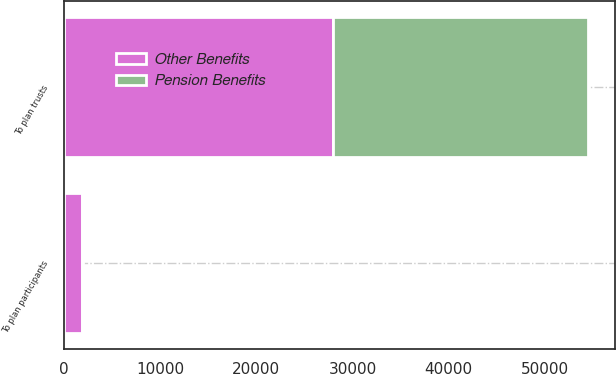Convert chart to OTSL. <chart><loc_0><loc_0><loc_500><loc_500><stacked_bar_chart><ecel><fcel>To plan trusts<fcel>To plan participants<nl><fcel>Other Benefits<fcel>28000<fcel>1929<nl><fcel>Pension Benefits<fcel>26500<fcel>104<nl></chart> 